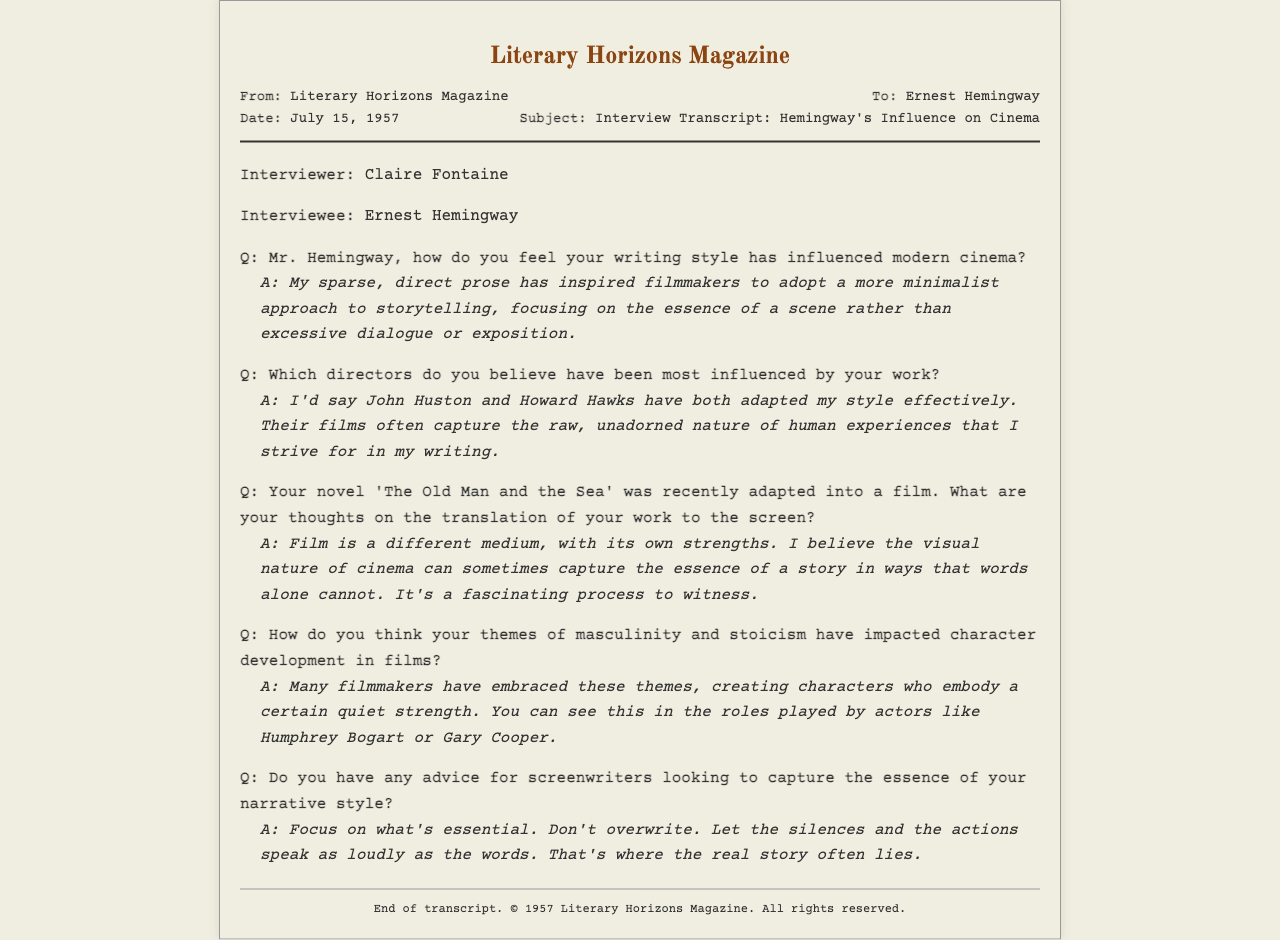What is the date of the interview? The document states that the interview took place on July 15, 1957.
Answer: July 15, 1957 Who is the interviewer? The fax indicates that Claire Fontaine conducted the interview.
Answer: Claire Fontaine Which novel was recently adapted into a film? The interview mentions 'The Old Man and the Sea' as a work that has been adapted.
Answer: The Old Man and the Sea What themes does Hemingway mention as impacting character development in films? The document states that masculinity and stoicism are themes that have influenced character development.
Answer: Masculinity and stoicism Who are two directors that Hemingway believes have been influenced by his work? Hemingway specifically names John Huston and Howard Hawks as influenced directors.
Answer: John Huston and Howard Hawks What is Hemingway’s advice to screenwriters? The interview includes his advice to focus on what's essential and to let actions speak.
Answer: Focus on what's essential What style does Hemingway attribute to influencing modern cinema? He claims his sparse, direct prose style has influenced a minimalist approach in storytelling.
Answer: Sparse, direct prose What actors does Hemingway associate with the themes in his work? He mentions Humphrey Bogart and Gary Cooper as actors embodying the themes of masculinity and stoicism.
Answer: Humphrey Bogart and Gary Cooper 